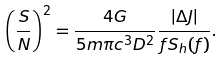<formula> <loc_0><loc_0><loc_500><loc_500>\left ( \frac { S } { N } \right ) ^ { 2 } = \frac { 4 G } { 5 m \pi c ^ { 3 } D ^ { 2 } } \frac { \left | \Delta J \right | } { f S _ { h } ( f ) } .</formula> 